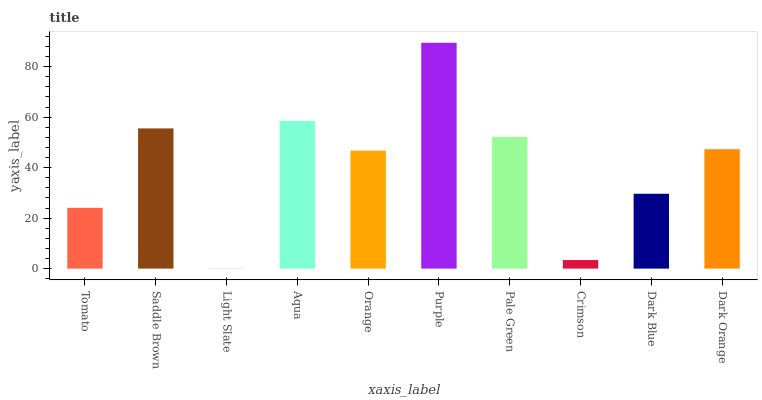Is Saddle Brown the minimum?
Answer yes or no. No. Is Saddle Brown the maximum?
Answer yes or no. No. Is Saddle Brown greater than Tomato?
Answer yes or no. Yes. Is Tomato less than Saddle Brown?
Answer yes or no. Yes. Is Tomato greater than Saddle Brown?
Answer yes or no. No. Is Saddle Brown less than Tomato?
Answer yes or no. No. Is Dark Orange the high median?
Answer yes or no. Yes. Is Orange the low median?
Answer yes or no. Yes. Is Pale Green the high median?
Answer yes or no. No. Is Aqua the low median?
Answer yes or no. No. 